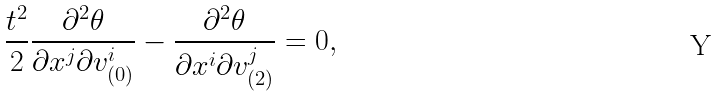<formula> <loc_0><loc_0><loc_500><loc_500>\frac { t ^ { 2 } } { 2 } \frac { \partial ^ { 2 } \theta } { \partial x ^ { j } \partial v _ { ( 0 ) } ^ { i } } - \frac { \partial ^ { 2 } \theta } { \partial x ^ { i } \partial v _ { ( 2 ) } ^ { j } } = 0 ,</formula> 